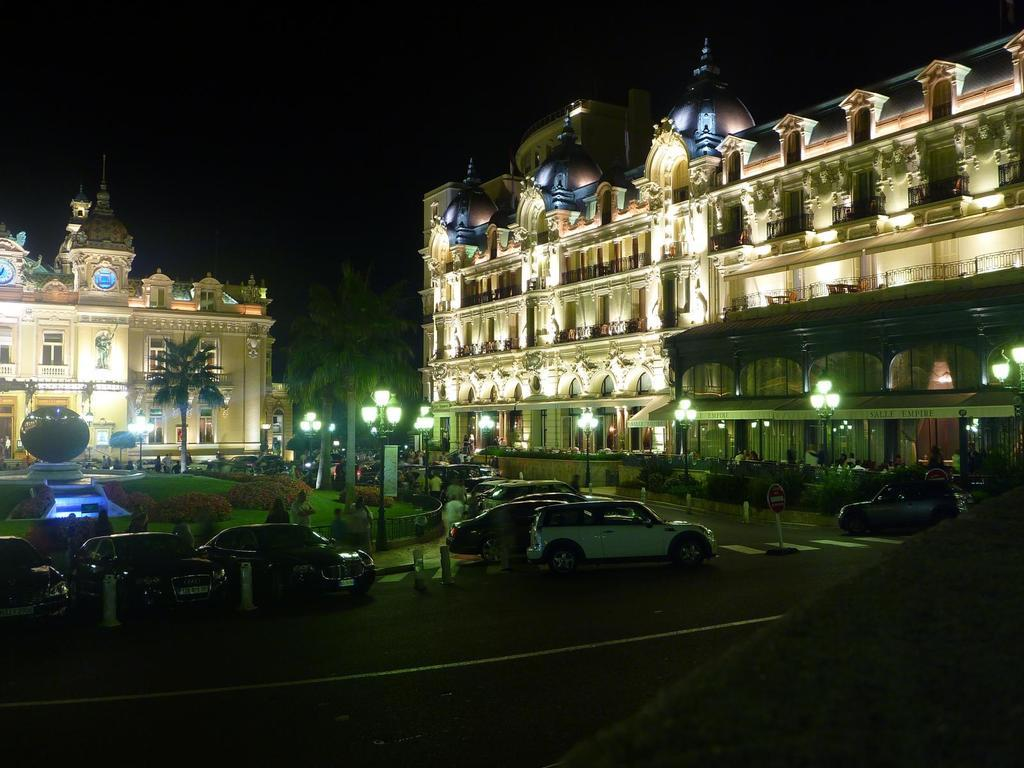What type of structures can be seen in the image? There are buildings and towers in the image. What are some other objects visible in the image? Street poles, street lights, trees, motor vehicles, bushes, a fountain, and sign boards are present in the image. What is the ground like in the image? The ground is visible in the image, and there is a road with margins. What can be seen in the sky in the image? The sky is visible in the image. How does the digestion process work for the power lines in the image? There are no power lines present in the image, and the concept of digestion does not apply to inanimate objects like power lines. How many rings are visible on the trees in the image? There are no rings visible on the trees in the image, as rings are typically found on tree trunks when they are cut down, and the image does not depict any cut trees. 